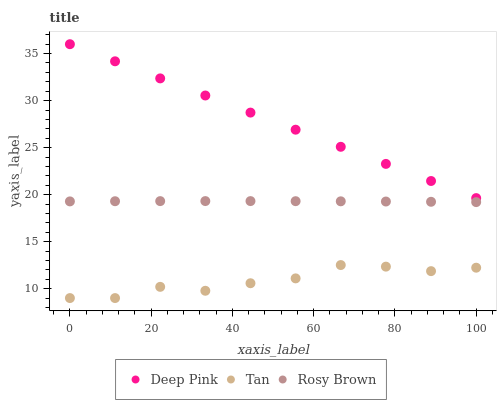Does Tan have the minimum area under the curve?
Answer yes or no. Yes. Does Deep Pink have the maximum area under the curve?
Answer yes or no. Yes. Does Rosy Brown have the minimum area under the curve?
Answer yes or no. No. Does Rosy Brown have the maximum area under the curve?
Answer yes or no. No. Is Deep Pink the smoothest?
Answer yes or no. Yes. Is Tan the roughest?
Answer yes or no. Yes. Is Rosy Brown the smoothest?
Answer yes or no. No. Is Rosy Brown the roughest?
Answer yes or no. No. Does Tan have the lowest value?
Answer yes or no. Yes. Does Rosy Brown have the lowest value?
Answer yes or no. No. Does Deep Pink have the highest value?
Answer yes or no. Yes. Does Rosy Brown have the highest value?
Answer yes or no. No. Is Rosy Brown less than Deep Pink?
Answer yes or no. Yes. Is Deep Pink greater than Rosy Brown?
Answer yes or no. Yes. Does Rosy Brown intersect Deep Pink?
Answer yes or no. No. 